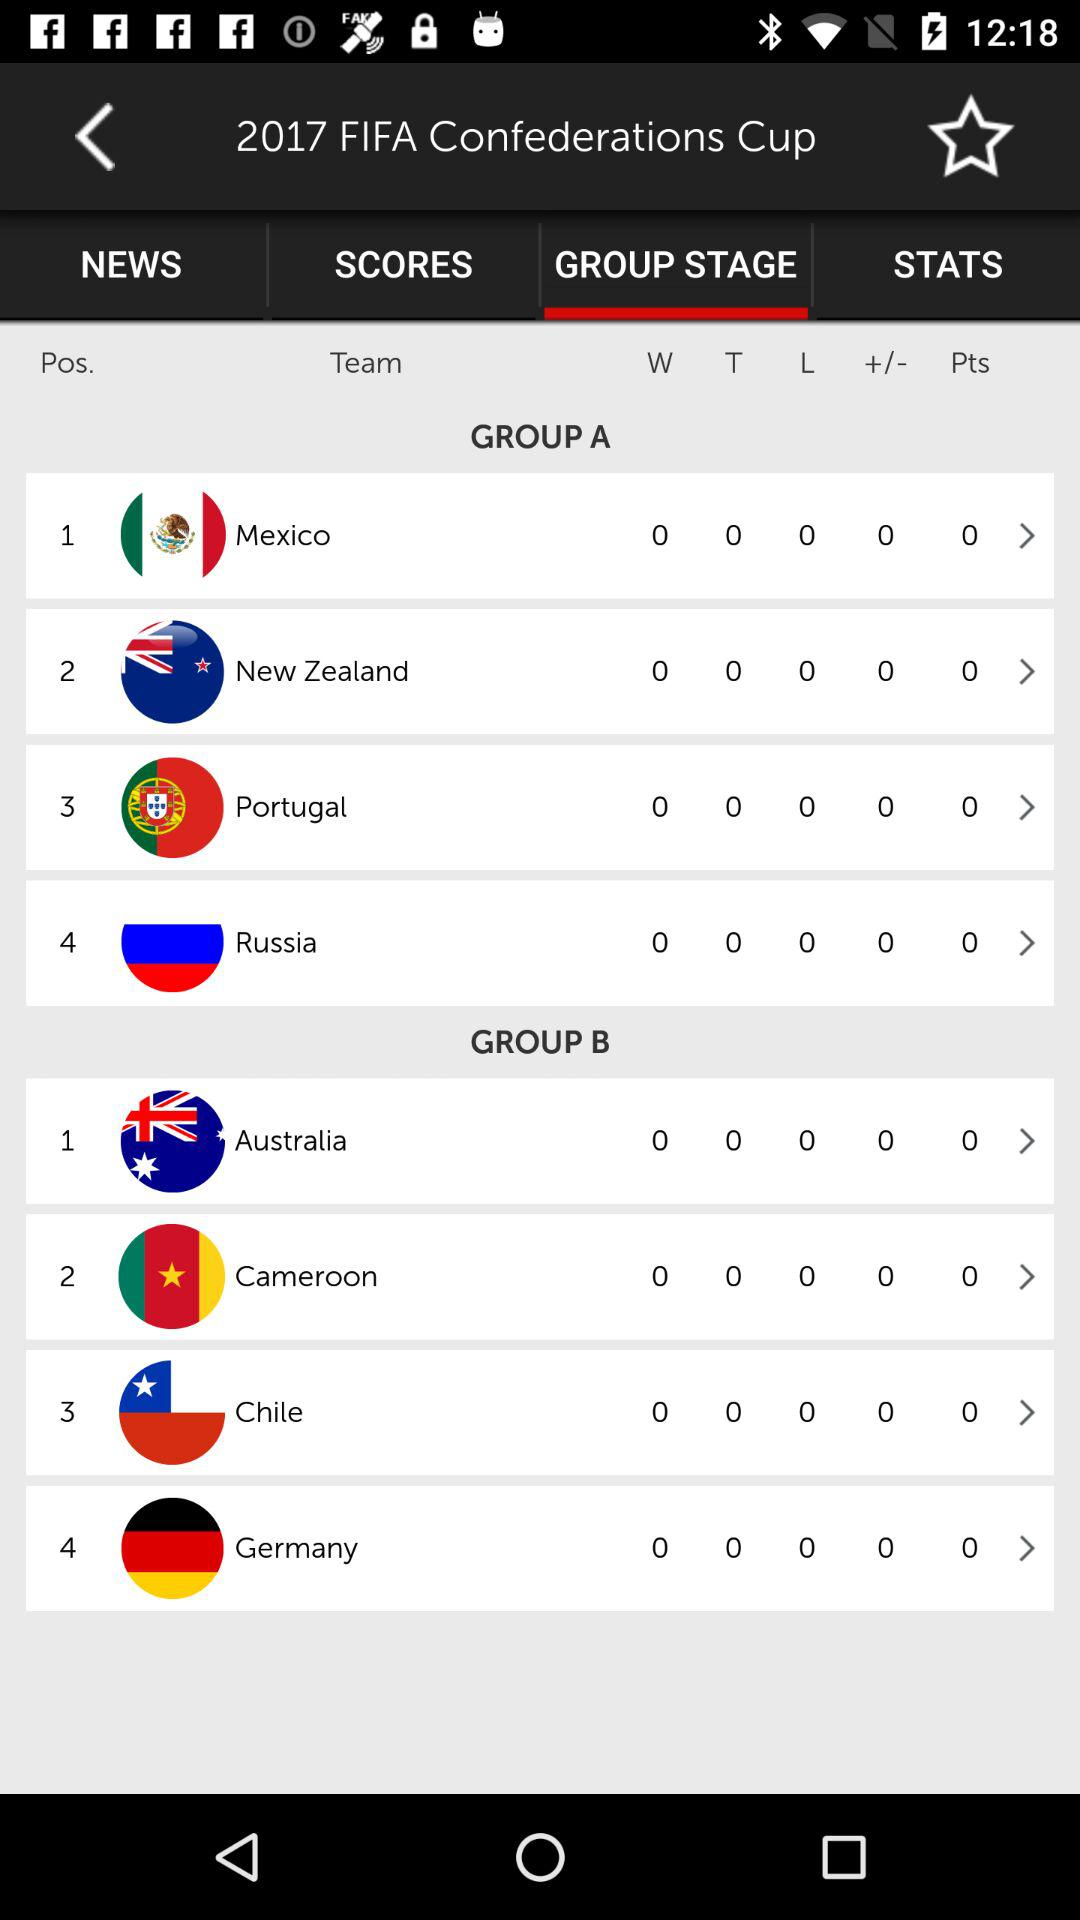What is the mentioned year for the FIFA Confederations Cup? The mentioned year is 2017. 